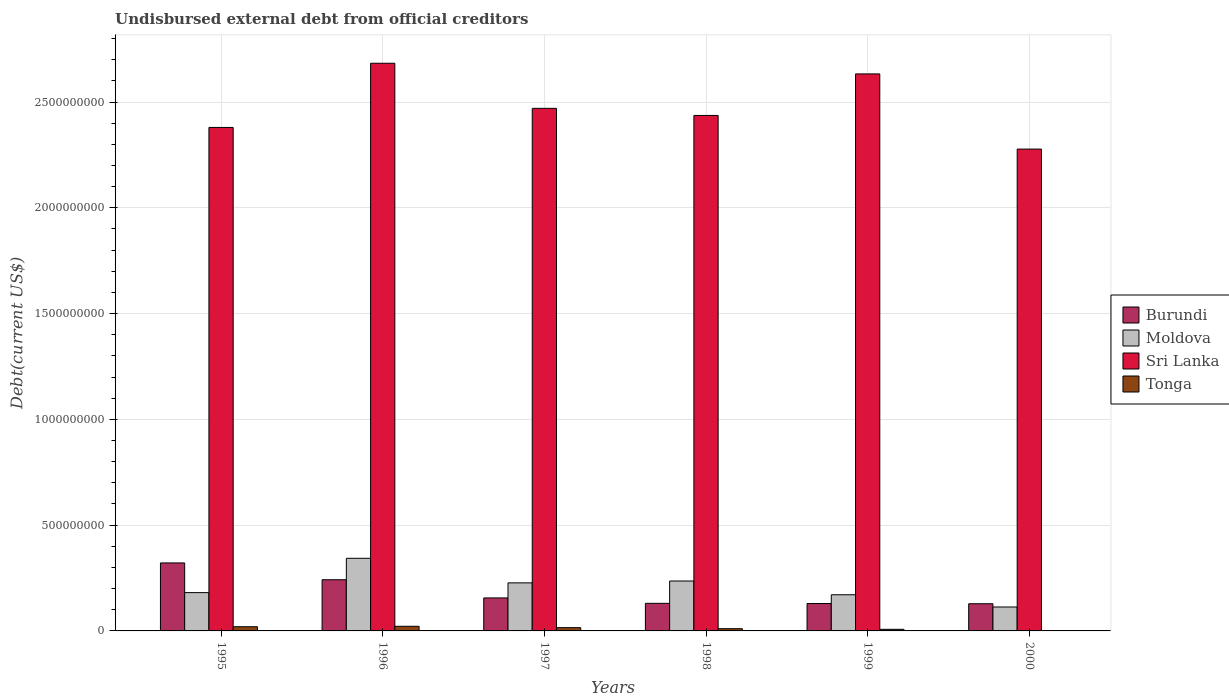Are the number of bars on each tick of the X-axis equal?
Give a very brief answer. Yes. How many bars are there on the 1st tick from the right?
Ensure brevity in your answer.  4. What is the label of the 5th group of bars from the left?
Your answer should be compact. 1999. In how many cases, is the number of bars for a given year not equal to the number of legend labels?
Provide a succinct answer. 0. What is the total debt in Tonga in 2000?
Your answer should be very brief. 1.98e+06. Across all years, what is the maximum total debt in Burundi?
Provide a short and direct response. 3.21e+08. Across all years, what is the minimum total debt in Tonga?
Offer a very short reply. 1.98e+06. In which year was the total debt in Moldova maximum?
Make the answer very short. 1996. What is the total total debt in Moldova in the graph?
Your answer should be very brief. 1.27e+09. What is the difference between the total debt in Moldova in 1996 and that in 1997?
Your answer should be compact. 1.16e+08. What is the difference between the total debt in Tonga in 1996 and the total debt in Sri Lanka in 1995?
Give a very brief answer. -2.36e+09. What is the average total debt in Burundi per year?
Offer a very short reply. 1.85e+08. In the year 1999, what is the difference between the total debt in Moldova and total debt in Sri Lanka?
Ensure brevity in your answer.  -2.46e+09. In how many years, is the total debt in Sri Lanka greater than 2500000000 US$?
Offer a terse response. 2. What is the ratio of the total debt in Tonga in 1995 to that in 1999?
Your answer should be compact. 2.62. Is the total debt in Burundi in 1995 less than that in 1998?
Provide a succinct answer. No. Is the difference between the total debt in Moldova in 1998 and 1999 greater than the difference between the total debt in Sri Lanka in 1998 and 1999?
Your response must be concise. Yes. What is the difference between the highest and the second highest total debt in Burundi?
Make the answer very short. 7.95e+07. What is the difference between the highest and the lowest total debt in Tonga?
Ensure brevity in your answer.  1.99e+07. In how many years, is the total debt in Moldova greater than the average total debt in Moldova taken over all years?
Provide a short and direct response. 3. Is the sum of the total debt in Tonga in 1998 and 1999 greater than the maximum total debt in Burundi across all years?
Your answer should be very brief. No. What does the 2nd bar from the left in 1995 represents?
Ensure brevity in your answer.  Moldova. What does the 4th bar from the right in 1998 represents?
Your answer should be very brief. Burundi. What is the difference between two consecutive major ticks on the Y-axis?
Your answer should be compact. 5.00e+08. Does the graph contain any zero values?
Provide a short and direct response. No. Does the graph contain grids?
Your response must be concise. Yes. Where does the legend appear in the graph?
Provide a short and direct response. Center right. What is the title of the graph?
Your response must be concise. Undisbursed external debt from official creditors. What is the label or title of the X-axis?
Your answer should be very brief. Years. What is the label or title of the Y-axis?
Your answer should be very brief. Debt(current US$). What is the Debt(current US$) in Burundi in 1995?
Offer a terse response. 3.21e+08. What is the Debt(current US$) in Moldova in 1995?
Your answer should be very brief. 1.81e+08. What is the Debt(current US$) in Sri Lanka in 1995?
Make the answer very short. 2.38e+09. What is the Debt(current US$) of Tonga in 1995?
Ensure brevity in your answer.  1.98e+07. What is the Debt(current US$) of Burundi in 1996?
Keep it short and to the point. 2.42e+08. What is the Debt(current US$) of Moldova in 1996?
Offer a terse response. 3.43e+08. What is the Debt(current US$) in Sri Lanka in 1996?
Make the answer very short. 2.68e+09. What is the Debt(current US$) in Tonga in 1996?
Ensure brevity in your answer.  2.19e+07. What is the Debt(current US$) of Burundi in 1997?
Your answer should be very brief. 1.56e+08. What is the Debt(current US$) of Moldova in 1997?
Ensure brevity in your answer.  2.27e+08. What is the Debt(current US$) of Sri Lanka in 1997?
Provide a succinct answer. 2.47e+09. What is the Debt(current US$) in Tonga in 1997?
Offer a terse response. 1.54e+07. What is the Debt(current US$) in Burundi in 1998?
Provide a short and direct response. 1.30e+08. What is the Debt(current US$) in Moldova in 1998?
Provide a short and direct response. 2.36e+08. What is the Debt(current US$) of Sri Lanka in 1998?
Your response must be concise. 2.44e+09. What is the Debt(current US$) of Tonga in 1998?
Give a very brief answer. 1.05e+07. What is the Debt(current US$) in Burundi in 1999?
Provide a succinct answer. 1.29e+08. What is the Debt(current US$) of Moldova in 1999?
Offer a very short reply. 1.71e+08. What is the Debt(current US$) of Sri Lanka in 1999?
Offer a terse response. 2.63e+09. What is the Debt(current US$) in Tonga in 1999?
Your answer should be compact. 7.56e+06. What is the Debt(current US$) in Burundi in 2000?
Offer a very short reply. 1.28e+08. What is the Debt(current US$) of Moldova in 2000?
Keep it short and to the point. 1.13e+08. What is the Debt(current US$) of Sri Lanka in 2000?
Your response must be concise. 2.28e+09. What is the Debt(current US$) of Tonga in 2000?
Your answer should be compact. 1.98e+06. Across all years, what is the maximum Debt(current US$) in Burundi?
Make the answer very short. 3.21e+08. Across all years, what is the maximum Debt(current US$) in Moldova?
Your answer should be very brief. 3.43e+08. Across all years, what is the maximum Debt(current US$) of Sri Lanka?
Your answer should be compact. 2.68e+09. Across all years, what is the maximum Debt(current US$) of Tonga?
Make the answer very short. 2.19e+07. Across all years, what is the minimum Debt(current US$) in Burundi?
Offer a terse response. 1.28e+08. Across all years, what is the minimum Debt(current US$) of Moldova?
Your answer should be compact. 1.13e+08. Across all years, what is the minimum Debt(current US$) in Sri Lanka?
Provide a short and direct response. 2.28e+09. Across all years, what is the minimum Debt(current US$) in Tonga?
Give a very brief answer. 1.98e+06. What is the total Debt(current US$) in Burundi in the graph?
Offer a terse response. 1.11e+09. What is the total Debt(current US$) of Moldova in the graph?
Make the answer very short. 1.27e+09. What is the total Debt(current US$) of Sri Lanka in the graph?
Make the answer very short. 1.49e+1. What is the total Debt(current US$) in Tonga in the graph?
Offer a very short reply. 7.72e+07. What is the difference between the Debt(current US$) in Burundi in 1995 and that in 1996?
Provide a short and direct response. 7.95e+07. What is the difference between the Debt(current US$) of Moldova in 1995 and that in 1996?
Provide a succinct answer. -1.62e+08. What is the difference between the Debt(current US$) in Sri Lanka in 1995 and that in 1996?
Give a very brief answer. -3.03e+08. What is the difference between the Debt(current US$) in Tonga in 1995 and that in 1996?
Ensure brevity in your answer.  -2.10e+06. What is the difference between the Debt(current US$) in Burundi in 1995 and that in 1997?
Your answer should be compact. 1.65e+08. What is the difference between the Debt(current US$) in Moldova in 1995 and that in 1997?
Provide a short and direct response. -4.61e+07. What is the difference between the Debt(current US$) in Sri Lanka in 1995 and that in 1997?
Make the answer very short. -9.02e+07. What is the difference between the Debt(current US$) in Tonga in 1995 and that in 1997?
Ensure brevity in your answer.  4.43e+06. What is the difference between the Debt(current US$) of Burundi in 1995 and that in 1998?
Your answer should be very brief. 1.91e+08. What is the difference between the Debt(current US$) of Moldova in 1995 and that in 1998?
Provide a succinct answer. -5.49e+07. What is the difference between the Debt(current US$) of Sri Lanka in 1995 and that in 1998?
Offer a very short reply. -5.67e+07. What is the difference between the Debt(current US$) in Tonga in 1995 and that in 1998?
Your response must be concise. 9.32e+06. What is the difference between the Debt(current US$) of Burundi in 1995 and that in 1999?
Offer a terse response. 1.92e+08. What is the difference between the Debt(current US$) of Moldova in 1995 and that in 1999?
Offer a very short reply. 1.01e+07. What is the difference between the Debt(current US$) in Sri Lanka in 1995 and that in 1999?
Your response must be concise. -2.53e+08. What is the difference between the Debt(current US$) in Tonga in 1995 and that in 1999?
Ensure brevity in your answer.  1.23e+07. What is the difference between the Debt(current US$) of Burundi in 1995 and that in 2000?
Ensure brevity in your answer.  1.93e+08. What is the difference between the Debt(current US$) in Moldova in 1995 and that in 2000?
Keep it short and to the point. 6.79e+07. What is the difference between the Debt(current US$) in Sri Lanka in 1995 and that in 2000?
Give a very brief answer. 1.02e+08. What is the difference between the Debt(current US$) of Tonga in 1995 and that in 2000?
Keep it short and to the point. 1.78e+07. What is the difference between the Debt(current US$) of Burundi in 1996 and that in 1997?
Your answer should be very brief. 8.59e+07. What is the difference between the Debt(current US$) of Moldova in 1996 and that in 1997?
Provide a succinct answer. 1.16e+08. What is the difference between the Debt(current US$) in Sri Lanka in 1996 and that in 1997?
Provide a short and direct response. 2.13e+08. What is the difference between the Debt(current US$) in Tonga in 1996 and that in 1997?
Ensure brevity in your answer.  6.52e+06. What is the difference between the Debt(current US$) in Burundi in 1996 and that in 1998?
Provide a succinct answer. 1.12e+08. What is the difference between the Debt(current US$) in Moldova in 1996 and that in 1998?
Your response must be concise. 1.07e+08. What is the difference between the Debt(current US$) in Sri Lanka in 1996 and that in 1998?
Offer a very short reply. 2.47e+08. What is the difference between the Debt(current US$) in Tonga in 1996 and that in 1998?
Your answer should be very brief. 1.14e+07. What is the difference between the Debt(current US$) in Burundi in 1996 and that in 1999?
Give a very brief answer. 1.12e+08. What is the difference between the Debt(current US$) in Moldova in 1996 and that in 1999?
Your answer should be very brief. 1.72e+08. What is the difference between the Debt(current US$) in Sri Lanka in 1996 and that in 1999?
Offer a very short reply. 5.04e+07. What is the difference between the Debt(current US$) in Tonga in 1996 and that in 1999?
Ensure brevity in your answer.  1.44e+07. What is the difference between the Debt(current US$) in Burundi in 1996 and that in 2000?
Give a very brief answer. 1.13e+08. What is the difference between the Debt(current US$) in Moldova in 1996 and that in 2000?
Provide a succinct answer. 2.30e+08. What is the difference between the Debt(current US$) of Sri Lanka in 1996 and that in 2000?
Your response must be concise. 4.06e+08. What is the difference between the Debt(current US$) of Tonga in 1996 and that in 2000?
Keep it short and to the point. 1.99e+07. What is the difference between the Debt(current US$) of Burundi in 1997 and that in 1998?
Provide a short and direct response. 2.56e+07. What is the difference between the Debt(current US$) of Moldova in 1997 and that in 1998?
Your answer should be compact. -8.76e+06. What is the difference between the Debt(current US$) of Sri Lanka in 1997 and that in 1998?
Give a very brief answer. 3.35e+07. What is the difference between the Debt(current US$) in Tonga in 1997 and that in 1998?
Your answer should be very brief. 4.89e+06. What is the difference between the Debt(current US$) of Burundi in 1997 and that in 1999?
Your response must be concise. 2.65e+07. What is the difference between the Debt(current US$) in Moldova in 1997 and that in 1999?
Provide a succinct answer. 5.62e+07. What is the difference between the Debt(current US$) in Sri Lanka in 1997 and that in 1999?
Your answer should be very brief. -1.63e+08. What is the difference between the Debt(current US$) in Tonga in 1997 and that in 1999?
Your answer should be very brief. 7.83e+06. What is the difference between the Debt(current US$) in Burundi in 1997 and that in 2000?
Provide a short and direct response. 2.75e+07. What is the difference between the Debt(current US$) in Moldova in 1997 and that in 2000?
Make the answer very short. 1.14e+08. What is the difference between the Debt(current US$) of Sri Lanka in 1997 and that in 2000?
Offer a terse response. 1.93e+08. What is the difference between the Debt(current US$) in Tonga in 1997 and that in 2000?
Give a very brief answer. 1.34e+07. What is the difference between the Debt(current US$) of Burundi in 1998 and that in 1999?
Ensure brevity in your answer.  9.02e+05. What is the difference between the Debt(current US$) of Moldova in 1998 and that in 1999?
Keep it short and to the point. 6.50e+07. What is the difference between the Debt(current US$) in Sri Lanka in 1998 and that in 1999?
Keep it short and to the point. -1.96e+08. What is the difference between the Debt(current US$) in Tonga in 1998 and that in 1999?
Keep it short and to the point. 2.94e+06. What is the difference between the Debt(current US$) in Burundi in 1998 and that in 2000?
Your answer should be very brief. 1.93e+06. What is the difference between the Debt(current US$) of Moldova in 1998 and that in 2000?
Provide a succinct answer. 1.23e+08. What is the difference between the Debt(current US$) of Sri Lanka in 1998 and that in 2000?
Offer a very short reply. 1.59e+08. What is the difference between the Debt(current US$) of Tonga in 1998 and that in 2000?
Your answer should be very brief. 8.53e+06. What is the difference between the Debt(current US$) of Burundi in 1999 and that in 2000?
Provide a short and direct response. 1.02e+06. What is the difference between the Debt(current US$) of Moldova in 1999 and that in 2000?
Offer a terse response. 5.78e+07. What is the difference between the Debt(current US$) in Sri Lanka in 1999 and that in 2000?
Offer a terse response. 3.55e+08. What is the difference between the Debt(current US$) of Tonga in 1999 and that in 2000?
Offer a terse response. 5.59e+06. What is the difference between the Debt(current US$) of Burundi in 1995 and the Debt(current US$) of Moldova in 1996?
Offer a very short reply. -2.19e+07. What is the difference between the Debt(current US$) of Burundi in 1995 and the Debt(current US$) of Sri Lanka in 1996?
Ensure brevity in your answer.  -2.36e+09. What is the difference between the Debt(current US$) in Burundi in 1995 and the Debt(current US$) in Tonga in 1996?
Keep it short and to the point. 2.99e+08. What is the difference between the Debt(current US$) in Moldova in 1995 and the Debt(current US$) in Sri Lanka in 1996?
Your answer should be compact. -2.50e+09. What is the difference between the Debt(current US$) of Moldova in 1995 and the Debt(current US$) of Tonga in 1996?
Provide a short and direct response. 1.59e+08. What is the difference between the Debt(current US$) of Sri Lanka in 1995 and the Debt(current US$) of Tonga in 1996?
Offer a very short reply. 2.36e+09. What is the difference between the Debt(current US$) of Burundi in 1995 and the Debt(current US$) of Moldova in 1997?
Ensure brevity in your answer.  9.42e+07. What is the difference between the Debt(current US$) of Burundi in 1995 and the Debt(current US$) of Sri Lanka in 1997?
Offer a very short reply. -2.15e+09. What is the difference between the Debt(current US$) in Burundi in 1995 and the Debt(current US$) in Tonga in 1997?
Provide a short and direct response. 3.06e+08. What is the difference between the Debt(current US$) of Moldova in 1995 and the Debt(current US$) of Sri Lanka in 1997?
Provide a short and direct response. -2.29e+09. What is the difference between the Debt(current US$) in Moldova in 1995 and the Debt(current US$) in Tonga in 1997?
Provide a short and direct response. 1.66e+08. What is the difference between the Debt(current US$) in Sri Lanka in 1995 and the Debt(current US$) in Tonga in 1997?
Your answer should be compact. 2.36e+09. What is the difference between the Debt(current US$) in Burundi in 1995 and the Debt(current US$) in Moldova in 1998?
Ensure brevity in your answer.  8.55e+07. What is the difference between the Debt(current US$) in Burundi in 1995 and the Debt(current US$) in Sri Lanka in 1998?
Offer a terse response. -2.12e+09. What is the difference between the Debt(current US$) of Burundi in 1995 and the Debt(current US$) of Tonga in 1998?
Ensure brevity in your answer.  3.11e+08. What is the difference between the Debt(current US$) of Moldova in 1995 and the Debt(current US$) of Sri Lanka in 1998?
Offer a very short reply. -2.26e+09. What is the difference between the Debt(current US$) of Moldova in 1995 and the Debt(current US$) of Tonga in 1998?
Give a very brief answer. 1.71e+08. What is the difference between the Debt(current US$) of Sri Lanka in 1995 and the Debt(current US$) of Tonga in 1998?
Offer a very short reply. 2.37e+09. What is the difference between the Debt(current US$) of Burundi in 1995 and the Debt(current US$) of Moldova in 1999?
Offer a terse response. 1.50e+08. What is the difference between the Debt(current US$) in Burundi in 1995 and the Debt(current US$) in Sri Lanka in 1999?
Give a very brief answer. -2.31e+09. What is the difference between the Debt(current US$) of Burundi in 1995 and the Debt(current US$) of Tonga in 1999?
Your response must be concise. 3.14e+08. What is the difference between the Debt(current US$) in Moldova in 1995 and the Debt(current US$) in Sri Lanka in 1999?
Your response must be concise. -2.45e+09. What is the difference between the Debt(current US$) of Moldova in 1995 and the Debt(current US$) of Tonga in 1999?
Keep it short and to the point. 1.73e+08. What is the difference between the Debt(current US$) in Sri Lanka in 1995 and the Debt(current US$) in Tonga in 1999?
Provide a short and direct response. 2.37e+09. What is the difference between the Debt(current US$) in Burundi in 1995 and the Debt(current US$) in Moldova in 2000?
Keep it short and to the point. 2.08e+08. What is the difference between the Debt(current US$) in Burundi in 1995 and the Debt(current US$) in Sri Lanka in 2000?
Give a very brief answer. -1.96e+09. What is the difference between the Debt(current US$) of Burundi in 1995 and the Debt(current US$) of Tonga in 2000?
Provide a succinct answer. 3.19e+08. What is the difference between the Debt(current US$) in Moldova in 1995 and the Debt(current US$) in Sri Lanka in 2000?
Your response must be concise. -2.10e+09. What is the difference between the Debt(current US$) of Moldova in 1995 and the Debt(current US$) of Tonga in 2000?
Provide a short and direct response. 1.79e+08. What is the difference between the Debt(current US$) in Sri Lanka in 1995 and the Debt(current US$) in Tonga in 2000?
Your answer should be compact. 2.38e+09. What is the difference between the Debt(current US$) of Burundi in 1996 and the Debt(current US$) of Moldova in 1997?
Keep it short and to the point. 1.47e+07. What is the difference between the Debt(current US$) in Burundi in 1996 and the Debt(current US$) in Sri Lanka in 1997?
Make the answer very short. -2.23e+09. What is the difference between the Debt(current US$) of Burundi in 1996 and the Debt(current US$) of Tonga in 1997?
Your response must be concise. 2.26e+08. What is the difference between the Debt(current US$) in Moldova in 1996 and the Debt(current US$) in Sri Lanka in 1997?
Provide a short and direct response. -2.13e+09. What is the difference between the Debt(current US$) of Moldova in 1996 and the Debt(current US$) of Tonga in 1997?
Your answer should be compact. 3.28e+08. What is the difference between the Debt(current US$) of Sri Lanka in 1996 and the Debt(current US$) of Tonga in 1997?
Keep it short and to the point. 2.67e+09. What is the difference between the Debt(current US$) of Burundi in 1996 and the Debt(current US$) of Moldova in 1998?
Make the answer very short. 5.96e+06. What is the difference between the Debt(current US$) in Burundi in 1996 and the Debt(current US$) in Sri Lanka in 1998?
Give a very brief answer. -2.19e+09. What is the difference between the Debt(current US$) in Burundi in 1996 and the Debt(current US$) in Tonga in 1998?
Your answer should be very brief. 2.31e+08. What is the difference between the Debt(current US$) of Moldova in 1996 and the Debt(current US$) of Sri Lanka in 1998?
Ensure brevity in your answer.  -2.09e+09. What is the difference between the Debt(current US$) in Moldova in 1996 and the Debt(current US$) in Tonga in 1998?
Your response must be concise. 3.33e+08. What is the difference between the Debt(current US$) in Sri Lanka in 1996 and the Debt(current US$) in Tonga in 1998?
Your answer should be very brief. 2.67e+09. What is the difference between the Debt(current US$) of Burundi in 1996 and the Debt(current US$) of Moldova in 1999?
Offer a very short reply. 7.09e+07. What is the difference between the Debt(current US$) of Burundi in 1996 and the Debt(current US$) of Sri Lanka in 1999?
Provide a short and direct response. -2.39e+09. What is the difference between the Debt(current US$) of Burundi in 1996 and the Debt(current US$) of Tonga in 1999?
Your response must be concise. 2.34e+08. What is the difference between the Debt(current US$) of Moldova in 1996 and the Debt(current US$) of Sri Lanka in 1999?
Keep it short and to the point. -2.29e+09. What is the difference between the Debt(current US$) of Moldova in 1996 and the Debt(current US$) of Tonga in 1999?
Keep it short and to the point. 3.36e+08. What is the difference between the Debt(current US$) in Sri Lanka in 1996 and the Debt(current US$) in Tonga in 1999?
Your response must be concise. 2.68e+09. What is the difference between the Debt(current US$) of Burundi in 1996 and the Debt(current US$) of Moldova in 2000?
Give a very brief answer. 1.29e+08. What is the difference between the Debt(current US$) in Burundi in 1996 and the Debt(current US$) in Sri Lanka in 2000?
Keep it short and to the point. -2.04e+09. What is the difference between the Debt(current US$) of Burundi in 1996 and the Debt(current US$) of Tonga in 2000?
Provide a short and direct response. 2.40e+08. What is the difference between the Debt(current US$) in Moldova in 1996 and the Debt(current US$) in Sri Lanka in 2000?
Your response must be concise. -1.93e+09. What is the difference between the Debt(current US$) of Moldova in 1996 and the Debt(current US$) of Tonga in 2000?
Give a very brief answer. 3.41e+08. What is the difference between the Debt(current US$) in Sri Lanka in 1996 and the Debt(current US$) in Tonga in 2000?
Your response must be concise. 2.68e+09. What is the difference between the Debt(current US$) in Burundi in 1997 and the Debt(current US$) in Moldova in 1998?
Your answer should be very brief. -8.00e+07. What is the difference between the Debt(current US$) in Burundi in 1997 and the Debt(current US$) in Sri Lanka in 1998?
Provide a succinct answer. -2.28e+09. What is the difference between the Debt(current US$) of Burundi in 1997 and the Debt(current US$) of Tonga in 1998?
Your response must be concise. 1.45e+08. What is the difference between the Debt(current US$) of Moldova in 1997 and the Debt(current US$) of Sri Lanka in 1998?
Make the answer very short. -2.21e+09. What is the difference between the Debt(current US$) of Moldova in 1997 and the Debt(current US$) of Tonga in 1998?
Offer a terse response. 2.17e+08. What is the difference between the Debt(current US$) of Sri Lanka in 1997 and the Debt(current US$) of Tonga in 1998?
Give a very brief answer. 2.46e+09. What is the difference between the Debt(current US$) of Burundi in 1997 and the Debt(current US$) of Moldova in 1999?
Keep it short and to the point. -1.50e+07. What is the difference between the Debt(current US$) in Burundi in 1997 and the Debt(current US$) in Sri Lanka in 1999?
Your answer should be compact. -2.48e+09. What is the difference between the Debt(current US$) in Burundi in 1997 and the Debt(current US$) in Tonga in 1999?
Provide a succinct answer. 1.48e+08. What is the difference between the Debt(current US$) in Moldova in 1997 and the Debt(current US$) in Sri Lanka in 1999?
Your answer should be compact. -2.41e+09. What is the difference between the Debt(current US$) of Moldova in 1997 and the Debt(current US$) of Tonga in 1999?
Your answer should be compact. 2.20e+08. What is the difference between the Debt(current US$) of Sri Lanka in 1997 and the Debt(current US$) of Tonga in 1999?
Provide a succinct answer. 2.46e+09. What is the difference between the Debt(current US$) of Burundi in 1997 and the Debt(current US$) of Moldova in 2000?
Your answer should be compact. 4.28e+07. What is the difference between the Debt(current US$) of Burundi in 1997 and the Debt(current US$) of Sri Lanka in 2000?
Your response must be concise. -2.12e+09. What is the difference between the Debt(current US$) of Burundi in 1997 and the Debt(current US$) of Tonga in 2000?
Your answer should be compact. 1.54e+08. What is the difference between the Debt(current US$) of Moldova in 1997 and the Debt(current US$) of Sri Lanka in 2000?
Make the answer very short. -2.05e+09. What is the difference between the Debt(current US$) in Moldova in 1997 and the Debt(current US$) in Tonga in 2000?
Your answer should be very brief. 2.25e+08. What is the difference between the Debt(current US$) in Sri Lanka in 1997 and the Debt(current US$) in Tonga in 2000?
Offer a terse response. 2.47e+09. What is the difference between the Debt(current US$) of Burundi in 1998 and the Debt(current US$) of Moldova in 1999?
Keep it short and to the point. -4.06e+07. What is the difference between the Debt(current US$) of Burundi in 1998 and the Debt(current US$) of Sri Lanka in 1999?
Your response must be concise. -2.50e+09. What is the difference between the Debt(current US$) in Burundi in 1998 and the Debt(current US$) in Tonga in 1999?
Provide a short and direct response. 1.23e+08. What is the difference between the Debt(current US$) in Moldova in 1998 and the Debt(current US$) in Sri Lanka in 1999?
Your answer should be compact. -2.40e+09. What is the difference between the Debt(current US$) of Moldova in 1998 and the Debt(current US$) of Tonga in 1999?
Your answer should be very brief. 2.28e+08. What is the difference between the Debt(current US$) of Sri Lanka in 1998 and the Debt(current US$) of Tonga in 1999?
Your answer should be compact. 2.43e+09. What is the difference between the Debt(current US$) of Burundi in 1998 and the Debt(current US$) of Moldova in 2000?
Your answer should be compact. 1.72e+07. What is the difference between the Debt(current US$) in Burundi in 1998 and the Debt(current US$) in Sri Lanka in 2000?
Your answer should be very brief. -2.15e+09. What is the difference between the Debt(current US$) in Burundi in 1998 and the Debt(current US$) in Tonga in 2000?
Provide a short and direct response. 1.28e+08. What is the difference between the Debt(current US$) in Moldova in 1998 and the Debt(current US$) in Sri Lanka in 2000?
Give a very brief answer. -2.04e+09. What is the difference between the Debt(current US$) of Moldova in 1998 and the Debt(current US$) of Tonga in 2000?
Your response must be concise. 2.34e+08. What is the difference between the Debt(current US$) in Sri Lanka in 1998 and the Debt(current US$) in Tonga in 2000?
Provide a succinct answer. 2.43e+09. What is the difference between the Debt(current US$) of Burundi in 1999 and the Debt(current US$) of Moldova in 2000?
Make the answer very short. 1.63e+07. What is the difference between the Debt(current US$) of Burundi in 1999 and the Debt(current US$) of Sri Lanka in 2000?
Ensure brevity in your answer.  -2.15e+09. What is the difference between the Debt(current US$) of Burundi in 1999 and the Debt(current US$) of Tonga in 2000?
Your answer should be very brief. 1.28e+08. What is the difference between the Debt(current US$) in Moldova in 1999 and the Debt(current US$) in Sri Lanka in 2000?
Your answer should be very brief. -2.11e+09. What is the difference between the Debt(current US$) of Moldova in 1999 and the Debt(current US$) of Tonga in 2000?
Offer a very short reply. 1.69e+08. What is the difference between the Debt(current US$) of Sri Lanka in 1999 and the Debt(current US$) of Tonga in 2000?
Your response must be concise. 2.63e+09. What is the average Debt(current US$) of Burundi per year?
Keep it short and to the point. 1.85e+08. What is the average Debt(current US$) of Moldova per year?
Offer a very short reply. 2.12e+08. What is the average Debt(current US$) in Sri Lanka per year?
Offer a very short reply. 2.48e+09. What is the average Debt(current US$) in Tonga per year?
Your answer should be compact. 1.29e+07. In the year 1995, what is the difference between the Debt(current US$) in Burundi and Debt(current US$) in Moldova?
Your answer should be compact. 1.40e+08. In the year 1995, what is the difference between the Debt(current US$) in Burundi and Debt(current US$) in Sri Lanka?
Ensure brevity in your answer.  -2.06e+09. In the year 1995, what is the difference between the Debt(current US$) in Burundi and Debt(current US$) in Tonga?
Your response must be concise. 3.02e+08. In the year 1995, what is the difference between the Debt(current US$) of Moldova and Debt(current US$) of Sri Lanka?
Offer a very short reply. -2.20e+09. In the year 1995, what is the difference between the Debt(current US$) in Moldova and Debt(current US$) in Tonga?
Ensure brevity in your answer.  1.61e+08. In the year 1995, what is the difference between the Debt(current US$) in Sri Lanka and Debt(current US$) in Tonga?
Give a very brief answer. 2.36e+09. In the year 1996, what is the difference between the Debt(current US$) of Burundi and Debt(current US$) of Moldova?
Ensure brevity in your answer.  -1.01e+08. In the year 1996, what is the difference between the Debt(current US$) of Burundi and Debt(current US$) of Sri Lanka?
Your response must be concise. -2.44e+09. In the year 1996, what is the difference between the Debt(current US$) of Burundi and Debt(current US$) of Tonga?
Provide a short and direct response. 2.20e+08. In the year 1996, what is the difference between the Debt(current US$) of Moldova and Debt(current US$) of Sri Lanka?
Provide a short and direct response. -2.34e+09. In the year 1996, what is the difference between the Debt(current US$) of Moldova and Debt(current US$) of Tonga?
Provide a short and direct response. 3.21e+08. In the year 1996, what is the difference between the Debt(current US$) of Sri Lanka and Debt(current US$) of Tonga?
Your answer should be compact. 2.66e+09. In the year 1997, what is the difference between the Debt(current US$) in Burundi and Debt(current US$) in Moldova?
Your response must be concise. -7.12e+07. In the year 1997, what is the difference between the Debt(current US$) in Burundi and Debt(current US$) in Sri Lanka?
Keep it short and to the point. -2.31e+09. In the year 1997, what is the difference between the Debt(current US$) of Burundi and Debt(current US$) of Tonga?
Make the answer very short. 1.41e+08. In the year 1997, what is the difference between the Debt(current US$) in Moldova and Debt(current US$) in Sri Lanka?
Make the answer very short. -2.24e+09. In the year 1997, what is the difference between the Debt(current US$) in Moldova and Debt(current US$) in Tonga?
Offer a terse response. 2.12e+08. In the year 1997, what is the difference between the Debt(current US$) of Sri Lanka and Debt(current US$) of Tonga?
Offer a very short reply. 2.45e+09. In the year 1998, what is the difference between the Debt(current US$) of Burundi and Debt(current US$) of Moldova?
Offer a terse response. -1.06e+08. In the year 1998, what is the difference between the Debt(current US$) of Burundi and Debt(current US$) of Sri Lanka?
Offer a terse response. -2.31e+09. In the year 1998, what is the difference between the Debt(current US$) of Burundi and Debt(current US$) of Tonga?
Provide a succinct answer. 1.20e+08. In the year 1998, what is the difference between the Debt(current US$) in Moldova and Debt(current US$) in Sri Lanka?
Provide a succinct answer. -2.20e+09. In the year 1998, what is the difference between the Debt(current US$) in Moldova and Debt(current US$) in Tonga?
Ensure brevity in your answer.  2.25e+08. In the year 1998, what is the difference between the Debt(current US$) of Sri Lanka and Debt(current US$) of Tonga?
Your response must be concise. 2.43e+09. In the year 1999, what is the difference between the Debt(current US$) in Burundi and Debt(current US$) in Moldova?
Give a very brief answer. -4.15e+07. In the year 1999, what is the difference between the Debt(current US$) in Burundi and Debt(current US$) in Sri Lanka?
Ensure brevity in your answer.  -2.50e+09. In the year 1999, what is the difference between the Debt(current US$) in Burundi and Debt(current US$) in Tonga?
Your response must be concise. 1.22e+08. In the year 1999, what is the difference between the Debt(current US$) of Moldova and Debt(current US$) of Sri Lanka?
Keep it short and to the point. -2.46e+09. In the year 1999, what is the difference between the Debt(current US$) of Moldova and Debt(current US$) of Tonga?
Offer a very short reply. 1.63e+08. In the year 1999, what is the difference between the Debt(current US$) of Sri Lanka and Debt(current US$) of Tonga?
Provide a succinct answer. 2.63e+09. In the year 2000, what is the difference between the Debt(current US$) of Burundi and Debt(current US$) of Moldova?
Offer a terse response. 1.53e+07. In the year 2000, what is the difference between the Debt(current US$) in Burundi and Debt(current US$) in Sri Lanka?
Make the answer very short. -2.15e+09. In the year 2000, what is the difference between the Debt(current US$) in Burundi and Debt(current US$) in Tonga?
Offer a very short reply. 1.26e+08. In the year 2000, what is the difference between the Debt(current US$) of Moldova and Debt(current US$) of Sri Lanka?
Keep it short and to the point. -2.16e+09. In the year 2000, what is the difference between the Debt(current US$) in Moldova and Debt(current US$) in Tonga?
Make the answer very short. 1.11e+08. In the year 2000, what is the difference between the Debt(current US$) in Sri Lanka and Debt(current US$) in Tonga?
Offer a very short reply. 2.28e+09. What is the ratio of the Debt(current US$) of Burundi in 1995 to that in 1996?
Make the answer very short. 1.33. What is the ratio of the Debt(current US$) in Moldova in 1995 to that in 1996?
Your response must be concise. 0.53. What is the ratio of the Debt(current US$) in Sri Lanka in 1995 to that in 1996?
Keep it short and to the point. 0.89. What is the ratio of the Debt(current US$) in Tonga in 1995 to that in 1996?
Make the answer very short. 0.9. What is the ratio of the Debt(current US$) of Burundi in 1995 to that in 1997?
Offer a very short reply. 2.06. What is the ratio of the Debt(current US$) of Moldova in 1995 to that in 1997?
Keep it short and to the point. 0.8. What is the ratio of the Debt(current US$) in Sri Lanka in 1995 to that in 1997?
Your response must be concise. 0.96. What is the ratio of the Debt(current US$) of Tonga in 1995 to that in 1997?
Provide a short and direct response. 1.29. What is the ratio of the Debt(current US$) of Burundi in 1995 to that in 1998?
Keep it short and to the point. 2.47. What is the ratio of the Debt(current US$) in Moldova in 1995 to that in 1998?
Ensure brevity in your answer.  0.77. What is the ratio of the Debt(current US$) of Sri Lanka in 1995 to that in 1998?
Keep it short and to the point. 0.98. What is the ratio of the Debt(current US$) in Tonga in 1995 to that in 1998?
Provide a succinct answer. 1.89. What is the ratio of the Debt(current US$) in Burundi in 1995 to that in 1999?
Provide a succinct answer. 2.48. What is the ratio of the Debt(current US$) in Moldova in 1995 to that in 1999?
Offer a very short reply. 1.06. What is the ratio of the Debt(current US$) of Sri Lanka in 1995 to that in 1999?
Provide a succinct answer. 0.9. What is the ratio of the Debt(current US$) in Tonga in 1995 to that in 1999?
Provide a short and direct response. 2.62. What is the ratio of the Debt(current US$) in Burundi in 1995 to that in 2000?
Offer a very short reply. 2.5. What is the ratio of the Debt(current US$) in Moldova in 1995 to that in 2000?
Provide a short and direct response. 1.6. What is the ratio of the Debt(current US$) of Sri Lanka in 1995 to that in 2000?
Offer a terse response. 1.04. What is the ratio of the Debt(current US$) in Tonga in 1995 to that in 2000?
Offer a very short reply. 10.04. What is the ratio of the Debt(current US$) in Burundi in 1996 to that in 1997?
Give a very brief answer. 1.55. What is the ratio of the Debt(current US$) in Moldova in 1996 to that in 1997?
Ensure brevity in your answer.  1.51. What is the ratio of the Debt(current US$) of Sri Lanka in 1996 to that in 1997?
Keep it short and to the point. 1.09. What is the ratio of the Debt(current US$) in Tonga in 1996 to that in 1997?
Keep it short and to the point. 1.42. What is the ratio of the Debt(current US$) in Burundi in 1996 to that in 1998?
Offer a terse response. 1.86. What is the ratio of the Debt(current US$) of Moldova in 1996 to that in 1998?
Your answer should be compact. 1.46. What is the ratio of the Debt(current US$) of Sri Lanka in 1996 to that in 1998?
Provide a short and direct response. 1.1. What is the ratio of the Debt(current US$) in Tonga in 1996 to that in 1998?
Provide a succinct answer. 2.09. What is the ratio of the Debt(current US$) of Burundi in 1996 to that in 1999?
Offer a very short reply. 1.87. What is the ratio of the Debt(current US$) in Moldova in 1996 to that in 1999?
Offer a very short reply. 2.01. What is the ratio of the Debt(current US$) in Sri Lanka in 1996 to that in 1999?
Your answer should be compact. 1.02. What is the ratio of the Debt(current US$) in Tonga in 1996 to that in 1999?
Keep it short and to the point. 2.9. What is the ratio of the Debt(current US$) in Burundi in 1996 to that in 2000?
Your answer should be compact. 1.88. What is the ratio of the Debt(current US$) in Moldova in 1996 to that in 2000?
Keep it short and to the point. 3.03. What is the ratio of the Debt(current US$) in Sri Lanka in 1996 to that in 2000?
Give a very brief answer. 1.18. What is the ratio of the Debt(current US$) in Tonga in 1996 to that in 2000?
Provide a succinct answer. 11.1. What is the ratio of the Debt(current US$) of Burundi in 1997 to that in 1998?
Your response must be concise. 1.2. What is the ratio of the Debt(current US$) in Moldova in 1997 to that in 1998?
Provide a succinct answer. 0.96. What is the ratio of the Debt(current US$) in Sri Lanka in 1997 to that in 1998?
Your response must be concise. 1.01. What is the ratio of the Debt(current US$) of Tonga in 1997 to that in 1998?
Ensure brevity in your answer.  1.47. What is the ratio of the Debt(current US$) of Burundi in 1997 to that in 1999?
Offer a terse response. 1.2. What is the ratio of the Debt(current US$) of Moldova in 1997 to that in 1999?
Keep it short and to the point. 1.33. What is the ratio of the Debt(current US$) in Sri Lanka in 1997 to that in 1999?
Your answer should be compact. 0.94. What is the ratio of the Debt(current US$) in Tonga in 1997 to that in 1999?
Provide a succinct answer. 2.04. What is the ratio of the Debt(current US$) in Burundi in 1997 to that in 2000?
Offer a very short reply. 1.21. What is the ratio of the Debt(current US$) of Moldova in 1997 to that in 2000?
Keep it short and to the point. 2.01. What is the ratio of the Debt(current US$) of Sri Lanka in 1997 to that in 2000?
Ensure brevity in your answer.  1.08. What is the ratio of the Debt(current US$) of Tonga in 1997 to that in 2000?
Make the answer very short. 7.79. What is the ratio of the Debt(current US$) of Burundi in 1998 to that in 1999?
Your answer should be very brief. 1.01. What is the ratio of the Debt(current US$) of Moldova in 1998 to that in 1999?
Give a very brief answer. 1.38. What is the ratio of the Debt(current US$) of Sri Lanka in 1998 to that in 1999?
Your response must be concise. 0.93. What is the ratio of the Debt(current US$) of Tonga in 1998 to that in 1999?
Keep it short and to the point. 1.39. What is the ratio of the Debt(current US$) of Moldova in 1998 to that in 2000?
Give a very brief answer. 2.09. What is the ratio of the Debt(current US$) of Sri Lanka in 1998 to that in 2000?
Provide a short and direct response. 1.07. What is the ratio of the Debt(current US$) of Tonga in 1998 to that in 2000?
Give a very brief answer. 5.32. What is the ratio of the Debt(current US$) in Burundi in 1999 to that in 2000?
Ensure brevity in your answer.  1.01. What is the ratio of the Debt(current US$) of Moldova in 1999 to that in 2000?
Offer a very short reply. 1.51. What is the ratio of the Debt(current US$) in Sri Lanka in 1999 to that in 2000?
Keep it short and to the point. 1.16. What is the ratio of the Debt(current US$) in Tonga in 1999 to that in 2000?
Make the answer very short. 3.83. What is the difference between the highest and the second highest Debt(current US$) in Burundi?
Provide a succinct answer. 7.95e+07. What is the difference between the highest and the second highest Debt(current US$) in Moldova?
Keep it short and to the point. 1.07e+08. What is the difference between the highest and the second highest Debt(current US$) in Sri Lanka?
Keep it short and to the point. 5.04e+07. What is the difference between the highest and the second highest Debt(current US$) of Tonga?
Provide a short and direct response. 2.10e+06. What is the difference between the highest and the lowest Debt(current US$) of Burundi?
Your answer should be compact. 1.93e+08. What is the difference between the highest and the lowest Debt(current US$) of Moldova?
Provide a succinct answer. 2.30e+08. What is the difference between the highest and the lowest Debt(current US$) of Sri Lanka?
Give a very brief answer. 4.06e+08. What is the difference between the highest and the lowest Debt(current US$) in Tonga?
Give a very brief answer. 1.99e+07. 